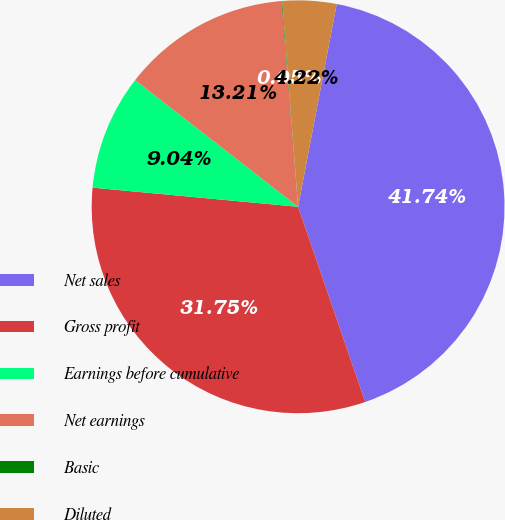Convert chart. <chart><loc_0><loc_0><loc_500><loc_500><pie_chart><fcel>Net sales<fcel>Gross profit<fcel>Earnings before cumulative<fcel>Net earnings<fcel>Basic<fcel>Diluted<nl><fcel>41.74%<fcel>31.75%<fcel>9.04%<fcel>13.21%<fcel>0.05%<fcel>4.22%<nl></chart> 